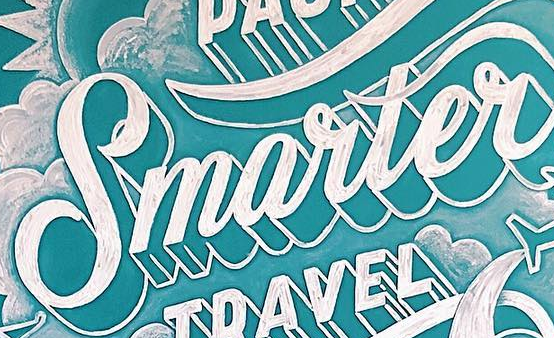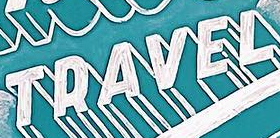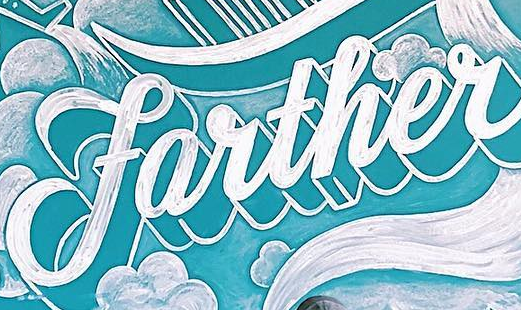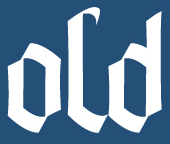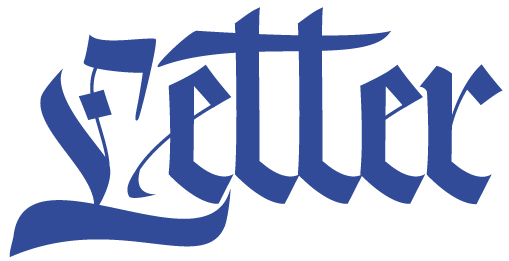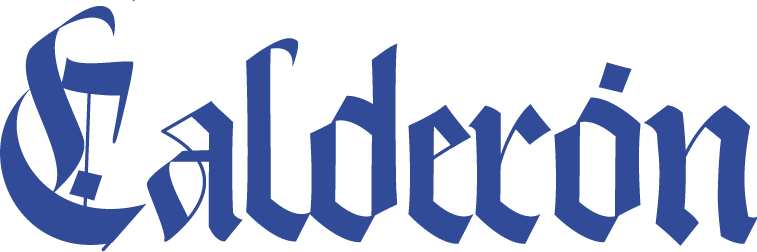What text appears in these images from left to right, separated by a semicolon? Smarter; TRAVEL; farther; old; Letter; Calderón 